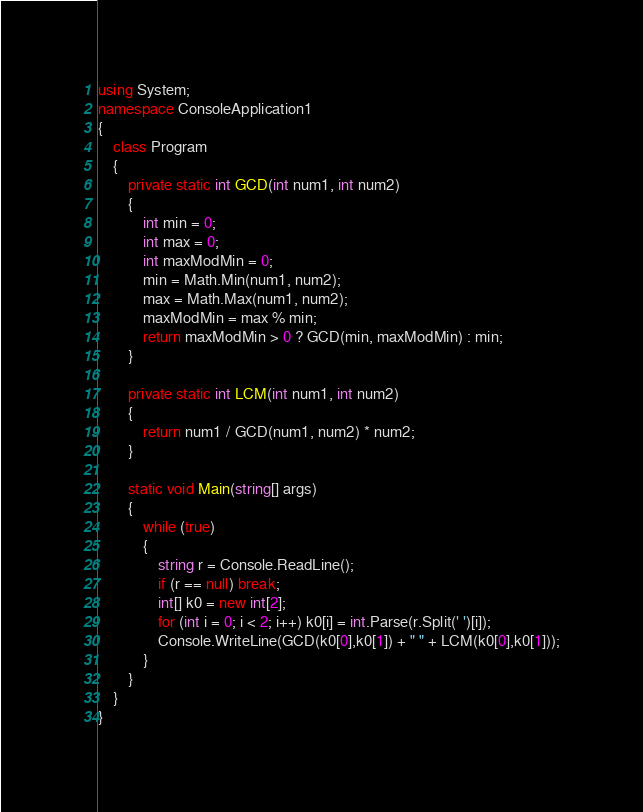Convert code to text. <code><loc_0><loc_0><loc_500><loc_500><_C#_>using System;
namespace ConsoleApplication1
{
    class Program
    {
        private static int GCD(int num1, int num2)
        {
            int min = 0;
            int max = 0;
            int maxModMin = 0;
            min = Math.Min(num1, num2);
            max = Math.Max(num1, num2);
            maxModMin = max % min;
            return maxModMin > 0 ? GCD(min, maxModMin) : min;
        }

        private static int LCM(int num1, int num2)
        {
            return num1 / GCD(num1, num2) * num2;
        }

        static void Main(string[] args)
        {
            while (true)
            {
                string r = Console.ReadLine();
                if (r == null) break;
                int[] k0 = new int[2];
                for (int i = 0; i < 2; i++) k0[i] = int.Parse(r.Split(' ')[i]);
                Console.WriteLine(GCD(k0[0],k0[1]) + " " + LCM(k0[0],k0[1]));
            }
        }
    }
}</code> 